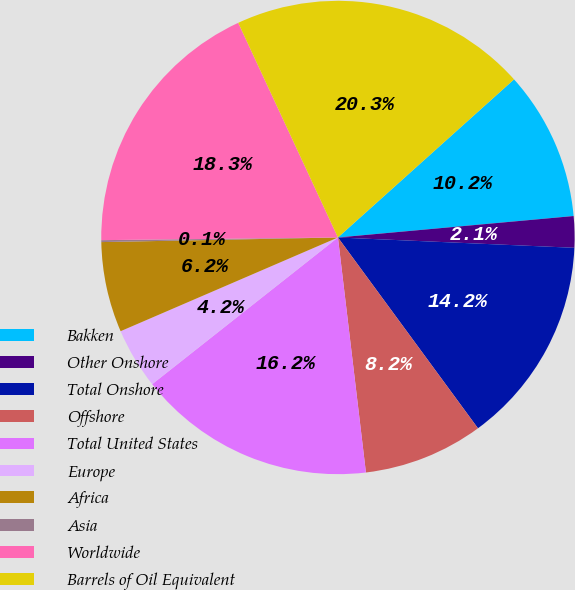Convert chart. <chart><loc_0><loc_0><loc_500><loc_500><pie_chart><fcel>Bakken<fcel>Other Onshore<fcel>Total Onshore<fcel>Offshore<fcel>Total United States<fcel>Europe<fcel>Africa<fcel>Asia<fcel>Worldwide<fcel>Barrels of Oil Equivalent<nl><fcel>10.2%<fcel>2.14%<fcel>14.23%<fcel>8.19%<fcel>16.25%<fcel>4.16%<fcel>6.17%<fcel>0.13%<fcel>18.26%<fcel>20.28%<nl></chart> 